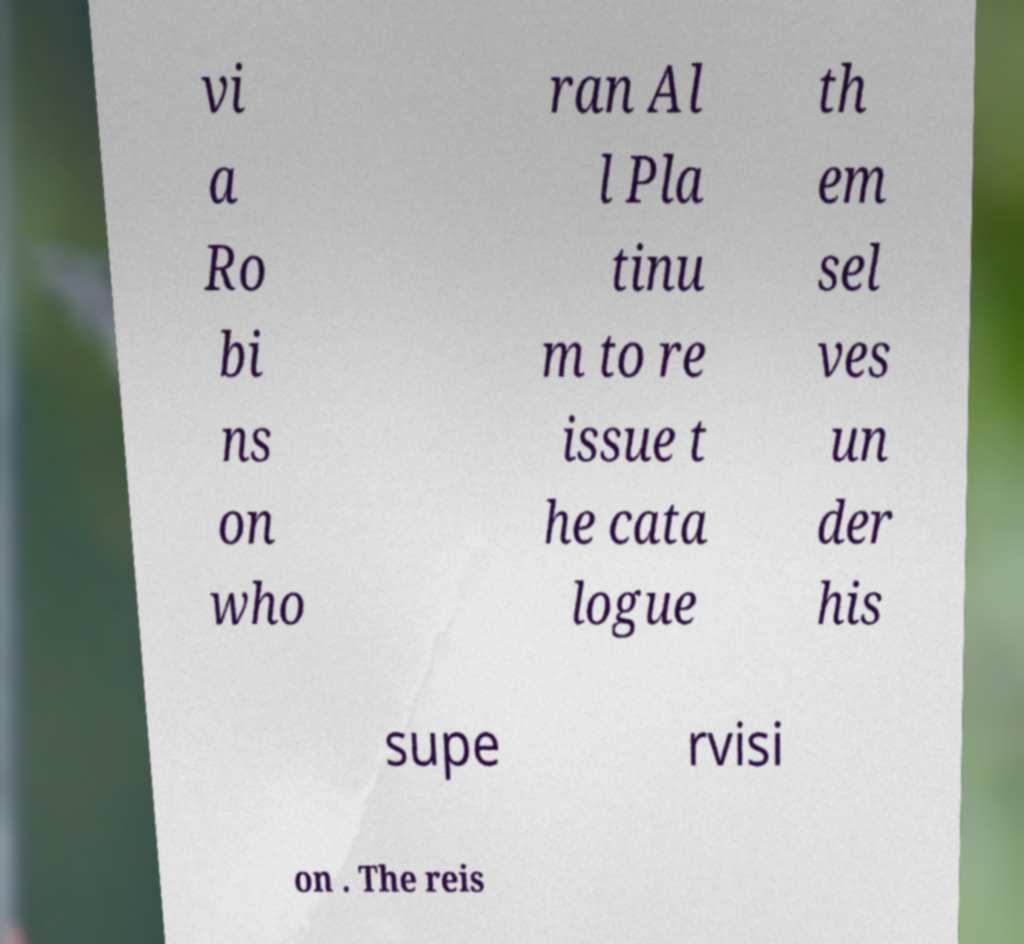Can you accurately transcribe the text from the provided image for me? vi a Ro bi ns on who ran Al l Pla tinu m to re issue t he cata logue th em sel ves un der his supe rvisi on . The reis 